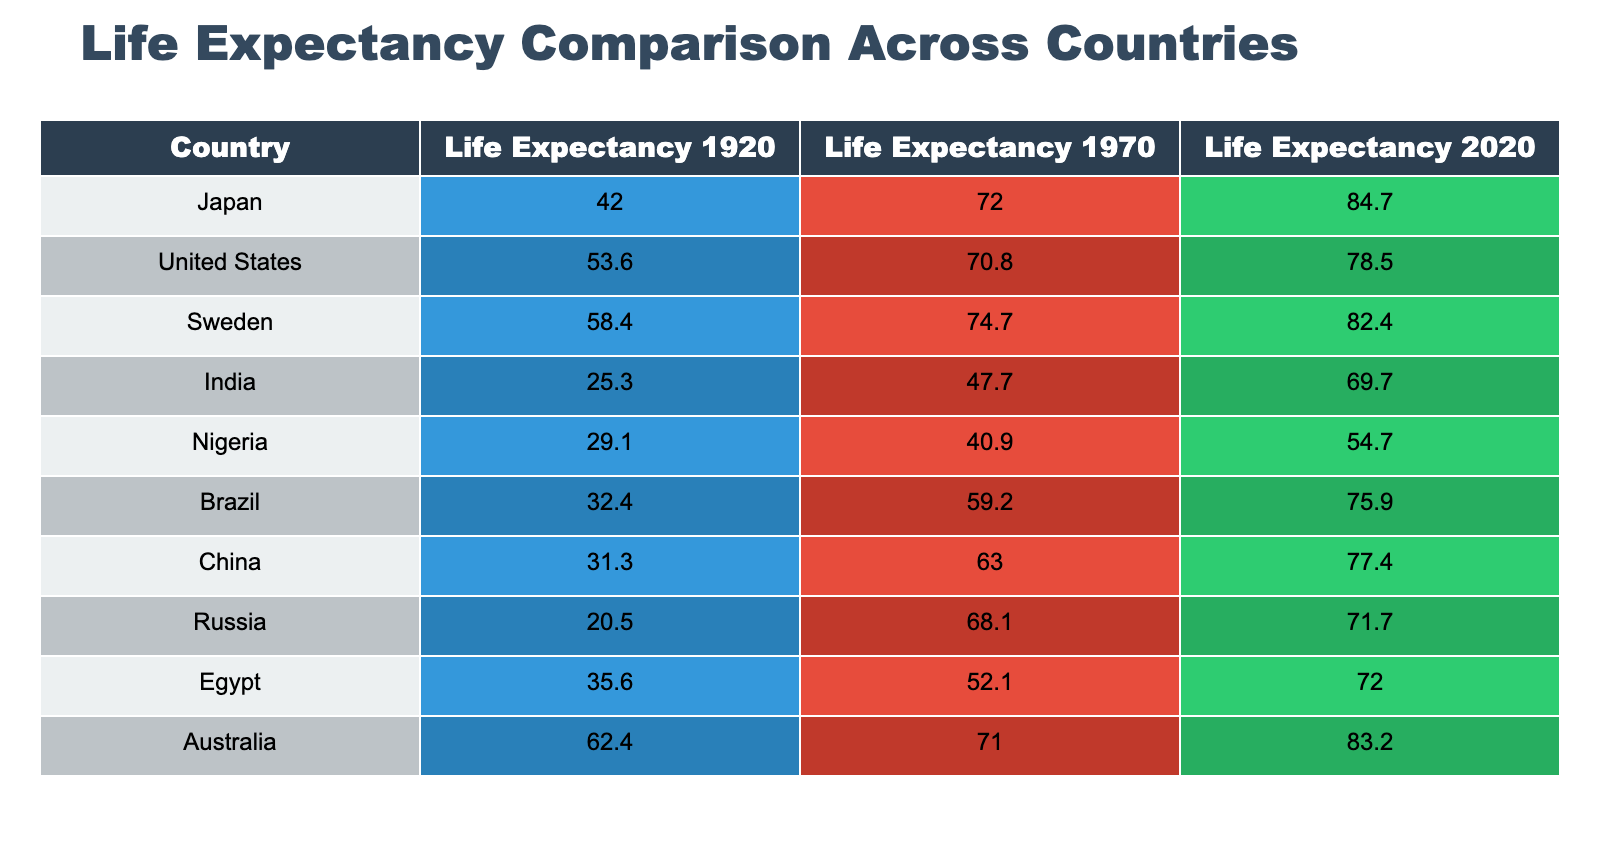What was the life expectancy of Japan in 1920? The table shows that Japan had a life expectancy of 42.0 in 1920, as indicated in the relevant cell of the table.
Answer: 42.0 Which country had the highest life expectancy in 2020? According to the table, Japan had the highest life expectancy in 2020, recorded at 84.7.
Answer: Japan What is the difference in life expectancy for the United States from 1970 to 2020? The life expectancy for the United States was 70.8 in 1970 and increased to 78.5 in 2020. The difference is calculated as 78.5 - 70.8 = 7.7.
Answer: 7.7 Is it true that Nigeria's life expectancy improved from 1920 to 2020? The table shows that Nigeria's life expectancy was 29.1 in 1920 and improved to 54.7 in 2020, indicating positive change. Thus, the statement is true.
Answer: Yes What was the average life expectancy in 1970 across the countries listed? To calculate the average life expectancy in 1970, we sum the individual life expectancies: 72.0 (Japan) + 70.8 (US) + 74.7 (Sweden) + 47.7 (India) + 40.9 (Nigeria) + 59.2 (Brazil) + 63.0 (China) + 68.1 (Russia) + 52.1 (Egypt) + 71.0 (Australia) =  578.5. Since there are 10 countries, the average is 578.5 / 10 = 57.85.
Answer: 57.85 How does China's life expectancy in 2020 compare to India's life expectancy in the same year? China's life expectancy in 2020 is 77.4, while India's is 69.7. The comparison shows that China has a higher life expectancy than India.
Answer: China has a higher life expectancy than India 